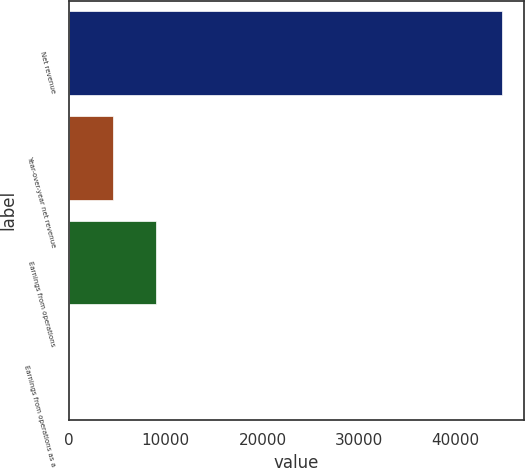<chart> <loc_0><loc_0><loc_500><loc_500><bar_chart><fcel>Net revenue<fcel>Year-over-year net revenue<fcel>Earnings from operations<fcel>Earnings from operations as a<nl><fcel>44826<fcel>4493.67<fcel>8975.04<fcel>12.3<nl></chart> 